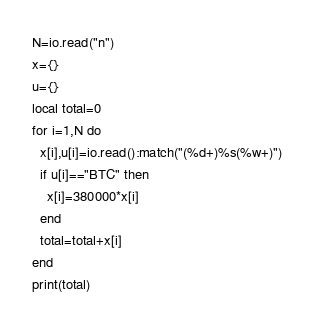Convert code to text. <code><loc_0><loc_0><loc_500><loc_500><_Lua_>N=io.read("n")
x={}
u={}
local total=0
for i=1,N do
  x[i],u[i]=io.read():match("(%d+)%s(%w+)")
  if u[i]=="BTC" then
    x[i]=380000*x[i]
  end
  total=total+x[i]
end
print(total)</code> 